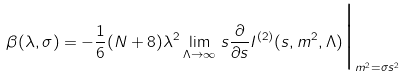<formula> <loc_0><loc_0><loc_500><loc_500>\beta ( \lambda , \sigma ) = - \frac { 1 } { 6 } ( N + 8 ) \lambda ^ { 2 } \lim _ { \Lambda \to \infty } \, s \frac { \partial } { \partial s } I ^ { ( 2 ) } ( s , m ^ { 2 } , \Lambda ) \Big | _ { m ^ { 2 } = \sigma s ^ { 2 } }</formula> 